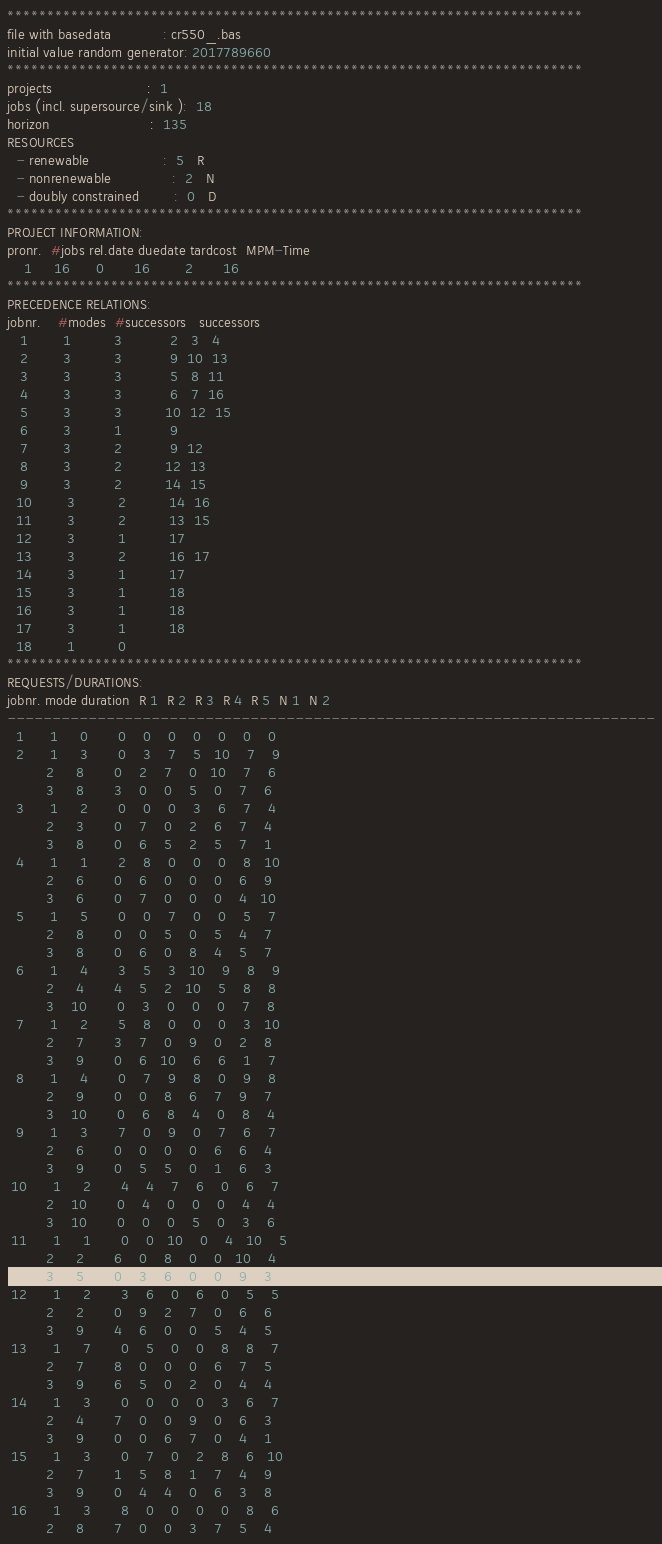<code> <loc_0><loc_0><loc_500><loc_500><_ObjectiveC_>************************************************************************
file with basedata            : cr550_.bas
initial value random generator: 2017789660
************************************************************************
projects                      :  1
jobs (incl. supersource/sink ):  18
horizon                       :  135
RESOURCES
  - renewable                 :  5   R
  - nonrenewable              :  2   N
  - doubly constrained        :  0   D
************************************************************************
PROJECT INFORMATION:
pronr.  #jobs rel.date duedate tardcost  MPM-Time
    1     16      0       16        2       16
************************************************************************
PRECEDENCE RELATIONS:
jobnr.    #modes  #successors   successors
   1        1          3           2   3   4
   2        3          3           9  10  13
   3        3          3           5   8  11
   4        3          3           6   7  16
   5        3          3          10  12  15
   6        3          1           9
   7        3          2           9  12
   8        3          2          12  13
   9        3          2          14  15
  10        3          2          14  16
  11        3          2          13  15
  12        3          1          17
  13        3          2          16  17
  14        3          1          17
  15        3          1          18
  16        3          1          18
  17        3          1          18
  18        1          0        
************************************************************************
REQUESTS/DURATIONS:
jobnr. mode duration  R 1  R 2  R 3  R 4  R 5  N 1  N 2
------------------------------------------------------------------------
  1      1     0       0    0    0    0    0    0    0
  2      1     3       0    3    7    5   10    7    9
         2     8       0    2    7    0   10    7    6
         3     8       3    0    0    5    0    7    6
  3      1     2       0    0    0    3    6    7    4
         2     3       0    7    0    2    6    7    4
         3     8       0    6    5    2    5    7    1
  4      1     1       2    8    0    0    0    8   10
         2     6       0    6    0    0    0    6    9
         3     6       0    7    0    0    0    4   10
  5      1     5       0    0    7    0    0    5    7
         2     8       0    0    5    0    5    4    7
         3     8       0    6    0    8    4    5    7
  6      1     4       3    5    3   10    9    8    9
         2     4       4    5    2   10    5    8    8
         3    10       0    3    0    0    0    7    8
  7      1     2       5    8    0    0    0    3   10
         2     7       3    7    0    9    0    2    8
         3     9       0    6   10    6    6    1    7
  8      1     4       0    7    9    8    0    9    8
         2     9       0    0    8    6    7    9    7
         3    10       0    6    8    4    0    8    4
  9      1     3       7    0    9    0    7    6    7
         2     6       0    0    0    0    6    6    4
         3     9       0    5    5    0    1    6    3
 10      1     2       4    4    7    6    0    6    7
         2    10       0    4    0    0    0    4    4
         3    10       0    0    0    5    0    3    6
 11      1     1       0    0   10    0    4   10    5
         2     2       6    0    8    0    0   10    4
         3     5       0    3    6    0    0    9    3
 12      1     2       3    6    0    6    0    5    5
         2     2       0    9    2    7    0    6    6
         3     9       4    6    0    0    5    4    5
 13      1     7       0    5    0    0    8    8    7
         2     7       8    0    0    0    6    7    5
         3     9       6    5    0    2    0    4    4
 14      1     3       0    0    0    0    3    6    7
         2     4       7    0    0    9    0    6    3
         3     9       0    0    6    7    0    4    1
 15      1     3       0    7    0    2    8    6   10
         2     7       1    5    8    1    7    4    9
         3     9       0    4    4    0    6    3    8
 16      1     3       8    0    0    0    0    8    6
         2     8       7    0    0    3    7    5    4</code> 